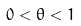Convert formula to latex. <formula><loc_0><loc_0><loc_500><loc_500>0 < \theta < 1</formula> 